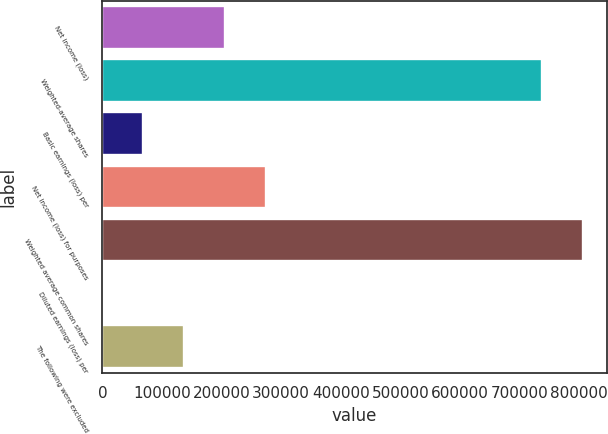Convert chart to OTSL. <chart><loc_0><loc_0><loc_500><loc_500><bar_chart><fcel>Net income (loss)<fcel>Weighted-average shares<fcel>Basic earnings (loss) per<fcel>Net income (loss) for purposes<fcel>Weighted average common shares<fcel>Diluted earnings (loss) per<fcel>The following were excluded<nl><fcel>206214<fcel>737127<fcel>68745.5<fcel>274949<fcel>805862<fcel>11.07<fcel>137480<nl></chart> 